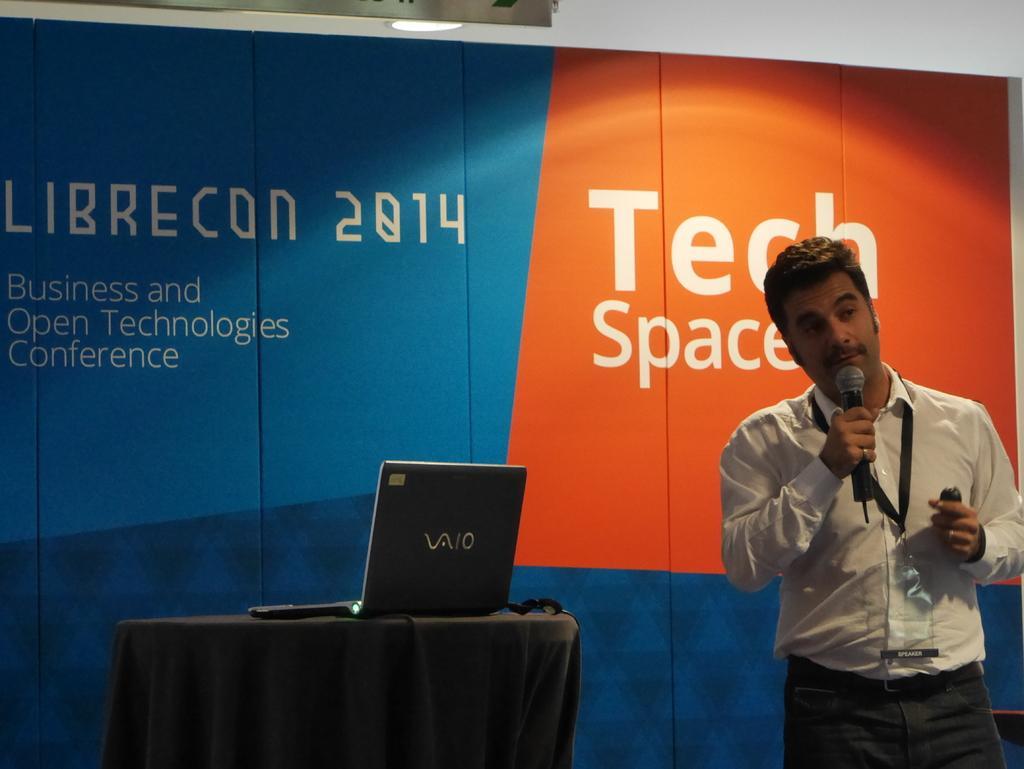Can you describe this image briefly? In the middle of the image there is a table, On the table there is a laptop. Bottom right side of the image a man is standing and holding a microphone, Behind him there is a banner. 